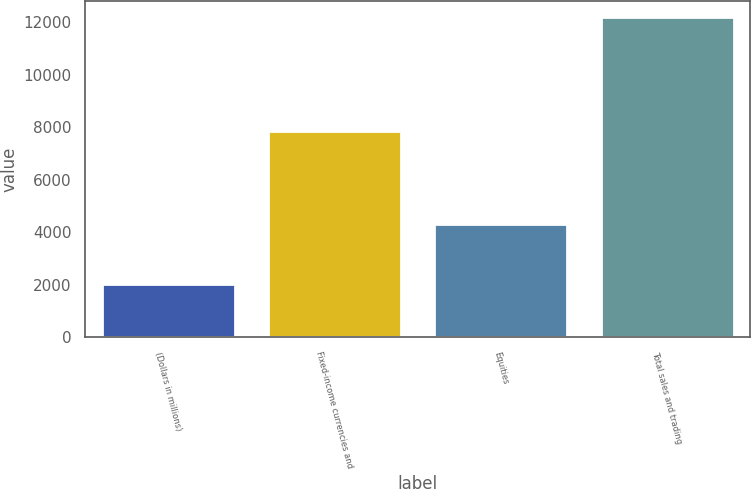Convert chart. <chart><loc_0><loc_0><loc_500><loc_500><bar_chart><fcel>(Dollars in millions)<fcel>Fixed-income currencies and<fcel>Equities<fcel>Total sales and trading<nl><fcel>2015<fcel>7869<fcel>4335<fcel>12204<nl></chart> 